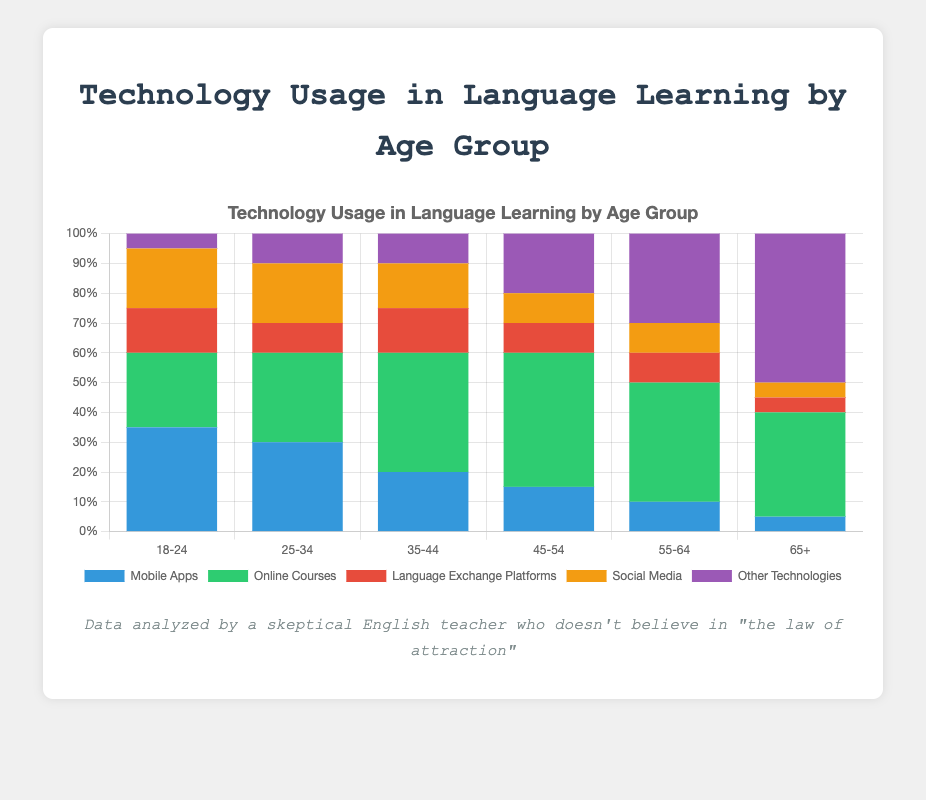What percentage of the 18-24 age group uses technologies other than Mobile Apps, Online Courses, and Social Media? To find this, sum up the percentages of the specified technologies for the 18-24 age group: Mobile Apps (35%), Online Courses (25%), and Social Media (20%). The sum is 35 + 25 + 20 = 80%. Subtract this from 100% to get the percentage using other technologies: 100 - 80 = 20%. Now, include the percentages for Language Exchange Platforms (15%) and Other Technologies (5%), which are already given.
Answer: 20% Which age group has the highest usage of Mobile Apps? Compare the Mobile Apps usage percentages across all age groups. They are: 18-24 (35%), 25-34 (30%), 35-44 (20%), 45-54 (15%), 55-64 (10%), 65+ (5%). The highest percentage is 35% for the 18-24 age group.
Answer: 18-24 How does the usage of Online Courses compare between the 25-34 and 45-54 age groups? Look at the Online Courses usage percentages for the 25-34 (30%) and 45-54 (45%) age groups. The 45-54 age group uses Online Courses 15% more than the 25-34 age group.
Answer: The 45-54 age group uses Online Courses 15% more Which technology shows a consistent increase in usage as the age group increases? Compare the percentages for each technology across all age groups. The only technology that consistently increases in usage with age is Other Technologies: 18-24 (5%), 25-34 (10%), 35-44 (10%), 45-54 (20%), 55-64 (30%), and 65+ (50%).
Answer: Other Technologies What is the combined usage percentage of Language Exchange Platforms and Social Media for the age group 35-44? Sum up the percentages of Language Exchange Platforms (15%) and Social Media (15%) for the 35-44 age group. The combined percentage is 15 + 15 = 30%.
Answer: 30% For the 65+ age group, what is the ratio of Online Courses usage to Mobile Apps usage? Look at the usage percentages for Online Courses (35%) and Mobile Apps (5%) in the 65+ age group. The ratio of Online Courses to Mobile Apps is 35/5 = 7.
Answer: 7:1 In which age group does Social Media have the same percentage as Language Exchange Platforms? Compare the percentages of Social Media and Language Exchange Platforms for each age group. The 25-34 age group has 20% for Social Media and 20% for Language Exchange Platforms.
Answer: 25-34 What is the total percentage of technology usage (all technologies combined) in the 35-44 age group? Sum up the usage percentages of all technologies in the 35-44 age group: Mobile Apps (20%), Online Courses (40%), Language Exchange Platforms (15%), Social Media (15%), and Other Technologies (10%). The total percentage is 20 + 40 + 15 + 15 + 10 = 100%.
Answer: 100% Which age group uses the least Social Media and what is the percentage? Compare the Social Media usage percentages across all age groups. The 65+ age group has the lowest percentage at 5%.
Answer: 65+, 5% How much higher is the usage of Other Technologies in the 65+ age group compared to the 18-24 age group? Subtract the Other Technologies usage percentage in the 18-24 age group (5%) from the 65+ age group (50%). 50 - 5 = 45%.
Answer: 45% 